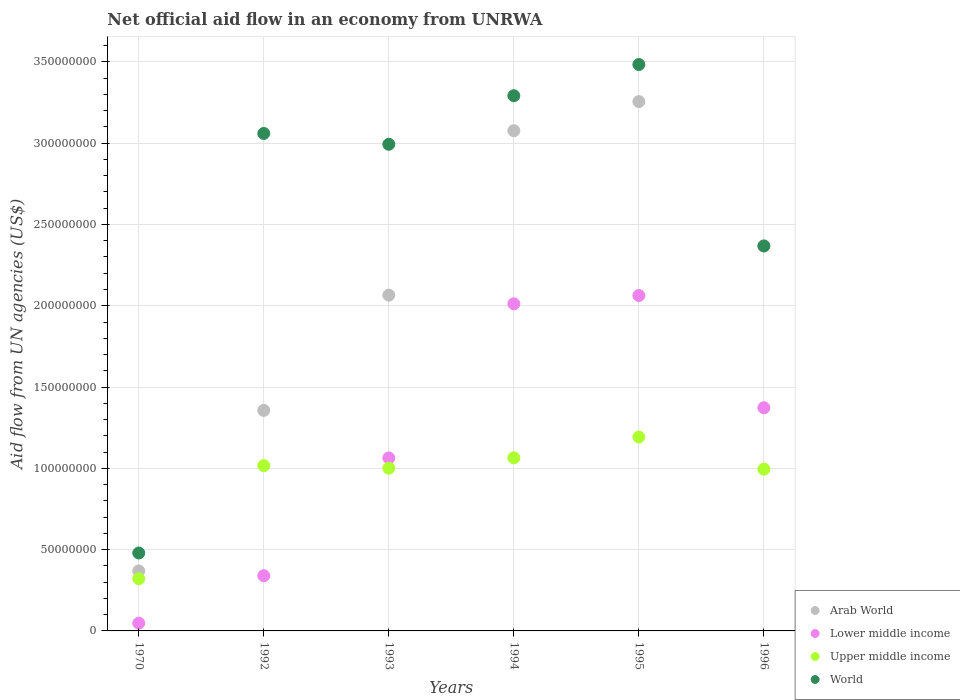How many different coloured dotlines are there?
Your answer should be compact. 4. What is the net official aid flow in Lower middle income in 1995?
Provide a short and direct response. 2.06e+08. Across all years, what is the maximum net official aid flow in Lower middle income?
Offer a terse response. 2.06e+08. Across all years, what is the minimum net official aid flow in Arab World?
Your answer should be very brief. 3.69e+07. In which year was the net official aid flow in Upper middle income maximum?
Ensure brevity in your answer.  1995. In which year was the net official aid flow in World minimum?
Provide a succinct answer. 1970. What is the total net official aid flow in World in the graph?
Your response must be concise. 1.57e+09. What is the difference between the net official aid flow in World in 1992 and that in 1994?
Keep it short and to the point. -2.32e+07. What is the difference between the net official aid flow in Lower middle income in 1993 and the net official aid flow in World in 1970?
Keep it short and to the point. 5.85e+07. What is the average net official aid flow in World per year?
Your answer should be compact. 2.61e+08. In the year 1970, what is the difference between the net official aid flow in Upper middle income and net official aid flow in Lower middle income?
Provide a short and direct response. 2.73e+07. In how many years, is the net official aid flow in World greater than 120000000 US$?
Your response must be concise. 5. What is the ratio of the net official aid flow in Upper middle income in 1970 to that in 1993?
Your response must be concise. 0.32. Is the net official aid flow in Lower middle income in 1992 less than that in 1993?
Ensure brevity in your answer.  Yes. Is the difference between the net official aid flow in Upper middle income in 1970 and 1994 greater than the difference between the net official aid flow in Lower middle income in 1970 and 1994?
Make the answer very short. Yes. What is the difference between the highest and the second highest net official aid flow in Arab World?
Your response must be concise. 1.79e+07. What is the difference between the highest and the lowest net official aid flow in World?
Your response must be concise. 3.00e+08. Is it the case that in every year, the sum of the net official aid flow in Lower middle income and net official aid flow in World  is greater than the sum of net official aid flow in Arab World and net official aid flow in Upper middle income?
Keep it short and to the point. No. Does the net official aid flow in Arab World monotonically increase over the years?
Offer a very short reply. No. Is the net official aid flow in World strictly less than the net official aid flow in Upper middle income over the years?
Provide a succinct answer. No. How many dotlines are there?
Your answer should be compact. 4. How many years are there in the graph?
Provide a succinct answer. 6. What is the difference between two consecutive major ticks on the Y-axis?
Ensure brevity in your answer.  5.00e+07. Does the graph contain grids?
Your response must be concise. Yes. Where does the legend appear in the graph?
Ensure brevity in your answer.  Bottom right. What is the title of the graph?
Give a very brief answer. Net official aid flow in an economy from UNRWA. What is the label or title of the Y-axis?
Your answer should be very brief. Aid flow from UN agencies (US$). What is the Aid flow from UN agencies (US$) of Arab World in 1970?
Ensure brevity in your answer.  3.69e+07. What is the Aid flow from UN agencies (US$) in Lower middle income in 1970?
Make the answer very short. 4.79e+06. What is the Aid flow from UN agencies (US$) of Upper middle income in 1970?
Offer a very short reply. 3.21e+07. What is the Aid flow from UN agencies (US$) of World in 1970?
Your answer should be compact. 4.79e+07. What is the Aid flow from UN agencies (US$) in Arab World in 1992?
Make the answer very short. 1.36e+08. What is the Aid flow from UN agencies (US$) of Lower middle income in 1992?
Your answer should be compact. 3.40e+07. What is the Aid flow from UN agencies (US$) in Upper middle income in 1992?
Offer a terse response. 1.02e+08. What is the Aid flow from UN agencies (US$) of World in 1992?
Your response must be concise. 3.06e+08. What is the Aid flow from UN agencies (US$) of Arab World in 1993?
Provide a succinct answer. 2.07e+08. What is the Aid flow from UN agencies (US$) of Lower middle income in 1993?
Offer a very short reply. 1.06e+08. What is the Aid flow from UN agencies (US$) in Upper middle income in 1993?
Your response must be concise. 1.00e+08. What is the Aid flow from UN agencies (US$) of World in 1993?
Keep it short and to the point. 2.99e+08. What is the Aid flow from UN agencies (US$) of Arab World in 1994?
Provide a succinct answer. 3.08e+08. What is the Aid flow from UN agencies (US$) of Lower middle income in 1994?
Provide a succinct answer. 2.01e+08. What is the Aid flow from UN agencies (US$) in Upper middle income in 1994?
Offer a very short reply. 1.06e+08. What is the Aid flow from UN agencies (US$) in World in 1994?
Offer a very short reply. 3.29e+08. What is the Aid flow from UN agencies (US$) in Arab World in 1995?
Ensure brevity in your answer.  3.26e+08. What is the Aid flow from UN agencies (US$) of Lower middle income in 1995?
Provide a succinct answer. 2.06e+08. What is the Aid flow from UN agencies (US$) in Upper middle income in 1995?
Provide a succinct answer. 1.19e+08. What is the Aid flow from UN agencies (US$) of World in 1995?
Your answer should be compact. 3.48e+08. What is the Aid flow from UN agencies (US$) of Arab World in 1996?
Ensure brevity in your answer.  2.37e+08. What is the Aid flow from UN agencies (US$) of Lower middle income in 1996?
Offer a terse response. 1.37e+08. What is the Aid flow from UN agencies (US$) in Upper middle income in 1996?
Offer a very short reply. 9.95e+07. What is the Aid flow from UN agencies (US$) in World in 1996?
Ensure brevity in your answer.  2.37e+08. Across all years, what is the maximum Aid flow from UN agencies (US$) in Arab World?
Offer a very short reply. 3.26e+08. Across all years, what is the maximum Aid flow from UN agencies (US$) of Lower middle income?
Offer a very short reply. 2.06e+08. Across all years, what is the maximum Aid flow from UN agencies (US$) of Upper middle income?
Your answer should be very brief. 1.19e+08. Across all years, what is the maximum Aid flow from UN agencies (US$) of World?
Offer a terse response. 3.48e+08. Across all years, what is the minimum Aid flow from UN agencies (US$) of Arab World?
Your response must be concise. 3.69e+07. Across all years, what is the minimum Aid flow from UN agencies (US$) in Lower middle income?
Provide a succinct answer. 4.79e+06. Across all years, what is the minimum Aid flow from UN agencies (US$) in Upper middle income?
Ensure brevity in your answer.  3.21e+07. Across all years, what is the minimum Aid flow from UN agencies (US$) of World?
Your response must be concise. 4.79e+07. What is the total Aid flow from UN agencies (US$) in Arab World in the graph?
Your response must be concise. 1.25e+09. What is the total Aid flow from UN agencies (US$) in Lower middle income in the graph?
Your response must be concise. 6.90e+08. What is the total Aid flow from UN agencies (US$) in Upper middle income in the graph?
Make the answer very short. 5.59e+08. What is the total Aid flow from UN agencies (US$) of World in the graph?
Keep it short and to the point. 1.57e+09. What is the difference between the Aid flow from UN agencies (US$) in Arab World in 1970 and that in 1992?
Provide a succinct answer. -9.87e+07. What is the difference between the Aid flow from UN agencies (US$) in Lower middle income in 1970 and that in 1992?
Provide a short and direct response. -2.92e+07. What is the difference between the Aid flow from UN agencies (US$) of Upper middle income in 1970 and that in 1992?
Your response must be concise. -6.96e+07. What is the difference between the Aid flow from UN agencies (US$) in World in 1970 and that in 1992?
Offer a terse response. -2.58e+08. What is the difference between the Aid flow from UN agencies (US$) in Arab World in 1970 and that in 1993?
Give a very brief answer. -1.70e+08. What is the difference between the Aid flow from UN agencies (US$) of Lower middle income in 1970 and that in 1993?
Provide a short and direct response. -1.02e+08. What is the difference between the Aid flow from UN agencies (US$) of Upper middle income in 1970 and that in 1993?
Your answer should be very brief. -6.80e+07. What is the difference between the Aid flow from UN agencies (US$) in World in 1970 and that in 1993?
Offer a terse response. -2.51e+08. What is the difference between the Aid flow from UN agencies (US$) of Arab World in 1970 and that in 1994?
Keep it short and to the point. -2.71e+08. What is the difference between the Aid flow from UN agencies (US$) of Lower middle income in 1970 and that in 1994?
Your answer should be compact. -1.96e+08. What is the difference between the Aid flow from UN agencies (US$) of Upper middle income in 1970 and that in 1994?
Your answer should be compact. -7.44e+07. What is the difference between the Aid flow from UN agencies (US$) of World in 1970 and that in 1994?
Offer a terse response. -2.81e+08. What is the difference between the Aid flow from UN agencies (US$) of Arab World in 1970 and that in 1995?
Provide a succinct answer. -2.89e+08. What is the difference between the Aid flow from UN agencies (US$) of Lower middle income in 1970 and that in 1995?
Offer a very short reply. -2.02e+08. What is the difference between the Aid flow from UN agencies (US$) in Upper middle income in 1970 and that in 1995?
Offer a very short reply. -8.72e+07. What is the difference between the Aid flow from UN agencies (US$) in World in 1970 and that in 1995?
Provide a short and direct response. -3.00e+08. What is the difference between the Aid flow from UN agencies (US$) of Arab World in 1970 and that in 1996?
Your answer should be compact. -2.00e+08. What is the difference between the Aid flow from UN agencies (US$) of Lower middle income in 1970 and that in 1996?
Your answer should be compact. -1.32e+08. What is the difference between the Aid flow from UN agencies (US$) of Upper middle income in 1970 and that in 1996?
Ensure brevity in your answer.  -6.74e+07. What is the difference between the Aid flow from UN agencies (US$) in World in 1970 and that in 1996?
Your answer should be very brief. -1.89e+08. What is the difference between the Aid flow from UN agencies (US$) in Arab World in 1992 and that in 1993?
Your response must be concise. -7.09e+07. What is the difference between the Aid flow from UN agencies (US$) of Lower middle income in 1992 and that in 1993?
Offer a very short reply. -7.24e+07. What is the difference between the Aid flow from UN agencies (US$) in Upper middle income in 1992 and that in 1993?
Your response must be concise. 1.57e+06. What is the difference between the Aid flow from UN agencies (US$) of World in 1992 and that in 1993?
Give a very brief answer. 6.65e+06. What is the difference between the Aid flow from UN agencies (US$) of Arab World in 1992 and that in 1994?
Your answer should be very brief. -1.72e+08. What is the difference between the Aid flow from UN agencies (US$) of Lower middle income in 1992 and that in 1994?
Offer a terse response. -1.67e+08. What is the difference between the Aid flow from UN agencies (US$) in Upper middle income in 1992 and that in 1994?
Offer a terse response. -4.80e+06. What is the difference between the Aid flow from UN agencies (US$) in World in 1992 and that in 1994?
Ensure brevity in your answer.  -2.32e+07. What is the difference between the Aid flow from UN agencies (US$) in Arab World in 1992 and that in 1995?
Ensure brevity in your answer.  -1.90e+08. What is the difference between the Aid flow from UN agencies (US$) of Lower middle income in 1992 and that in 1995?
Your answer should be very brief. -1.72e+08. What is the difference between the Aid flow from UN agencies (US$) of Upper middle income in 1992 and that in 1995?
Make the answer very short. -1.76e+07. What is the difference between the Aid flow from UN agencies (US$) in World in 1992 and that in 1995?
Your response must be concise. -4.24e+07. What is the difference between the Aid flow from UN agencies (US$) in Arab World in 1992 and that in 1996?
Provide a short and direct response. -1.01e+08. What is the difference between the Aid flow from UN agencies (US$) of Lower middle income in 1992 and that in 1996?
Make the answer very short. -1.03e+08. What is the difference between the Aid flow from UN agencies (US$) in Upper middle income in 1992 and that in 1996?
Keep it short and to the point. 2.18e+06. What is the difference between the Aid flow from UN agencies (US$) of World in 1992 and that in 1996?
Give a very brief answer. 6.92e+07. What is the difference between the Aid flow from UN agencies (US$) in Arab World in 1993 and that in 1994?
Offer a very short reply. -1.01e+08. What is the difference between the Aid flow from UN agencies (US$) in Lower middle income in 1993 and that in 1994?
Your answer should be compact. -9.48e+07. What is the difference between the Aid flow from UN agencies (US$) in Upper middle income in 1993 and that in 1994?
Ensure brevity in your answer.  -6.37e+06. What is the difference between the Aid flow from UN agencies (US$) in World in 1993 and that in 1994?
Give a very brief answer. -2.99e+07. What is the difference between the Aid flow from UN agencies (US$) of Arab World in 1993 and that in 1995?
Provide a succinct answer. -1.19e+08. What is the difference between the Aid flow from UN agencies (US$) in Lower middle income in 1993 and that in 1995?
Offer a terse response. -9.99e+07. What is the difference between the Aid flow from UN agencies (US$) of Upper middle income in 1993 and that in 1995?
Give a very brief answer. -1.92e+07. What is the difference between the Aid flow from UN agencies (US$) of World in 1993 and that in 1995?
Give a very brief answer. -4.91e+07. What is the difference between the Aid flow from UN agencies (US$) in Arab World in 1993 and that in 1996?
Your response must be concise. -3.03e+07. What is the difference between the Aid flow from UN agencies (US$) of Lower middle income in 1993 and that in 1996?
Give a very brief answer. -3.09e+07. What is the difference between the Aid flow from UN agencies (US$) in Upper middle income in 1993 and that in 1996?
Provide a succinct answer. 6.10e+05. What is the difference between the Aid flow from UN agencies (US$) of World in 1993 and that in 1996?
Your answer should be very brief. 6.26e+07. What is the difference between the Aid flow from UN agencies (US$) in Arab World in 1994 and that in 1995?
Give a very brief answer. -1.79e+07. What is the difference between the Aid flow from UN agencies (US$) in Lower middle income in 1994 and that in 1995?
Keep it short and to the point. -5.11e+06. What is the difference between the Aid flow from UN agencies (US$) in Upper middle income in 1994 and that in 1995?
Your answer should be very brief. -1.28e+07. What is the difference between the Aid flow from UN agencies (US$) in World in 1994 and that in 1995?
Make the answer very short. -1.92e+07. What is the difference between the Aid flow from UN agencies (US$) of Arab World in 1994 and that in 1996?
Your response must be concise. 7.09e+07. What is the difference between the Aid flow from UN agencies (US$) of Lower middle income in 1994 and that in 1996?
Make the answer very short. 6.39e+07. What is the difference between the Aid flow from UN agencies (US$) of Upper middle income in 1994 and that in 1996?
Provide a succinct answer. 6.98e+06. What is the difference between the Aid flow from UN agencies (US$) in World in 1994 and that in 1996?
Provide a succinct answer. 9.24e+07. What is the difference between the Aid flow from UN agencies (US$) of Arab World in 1995 and that in 1996?
Keep it short and to the point. 8.88e+07. What is the difference between the Aid flow from UN agencies (US$) of Lower middle income in 1995 and that in 1996?
Provide a short and direct response. 6.90e+07. What is the difference between the Aid flow from UN agencies (US$) of Upper middle income in 1995 and that in 1996?
Make the answer very short. 1.98e+07. What is the difference between the Aid flow from UN agencies (US$) in World in 1995 and that in 1996?
Provide a succinct answer. 1.12e+08. What is the difference between the Aid flow from UN agencies (US$) in Arab World in 1970 and the Aid flow from UN agencies (US$) in Lower middle income in 1992?
Make the answer very short. 2.95e+06. What is the difference between the Aid flow from UN agencies (US$) in Arab World in 1970 and the Aid flow from UN agencies (US$) in Upper middle income in 1992?
Make the answer very short. -6.48e+07. What is the difference between the Aid flow from UN agencies (US$) of Arab World in 1970 and the Aid flow from UN agencies (US$) of World in 1992?
Offer a terse response. -2.69e+08. What is the difference between the Aid flow from UN agencies (US$) in Lower middle income in 1970 and the Aid flow from UN agencies (US$) in Upper middle income in 1992?
Make the answer very short. -9.69e+07. What is the difference between the Aid flow from UN agencies (US$) of Lower middle income in 1970 and the Aid flow from UN agencies (US$) of World in 1992?
Keep it short and to the point. -3.01e+08. What is the difference between the Aid flow from UN agencies (US$) of Upper middle income in 1970 and the Aid flow from UN agencies (US$) of World in 1992?
Your answer should be very brief. -2.74e+08. What is the difference between the Aid flow from UN agencies (US$) in Arab World in 1970 and the Aid flow from UN agencies (US$) in Lower middle income in 1993?
Give a very brief answer. -6.95e+07. What is the difference between the Aid flow from UN agencies (US$) in Arab World in 1970 and the Aid flow from UN agencies (US$) in Upper middle income in 1993?
Your response must be concise. -6.32e+07. What is the difference between the Aid flow from UN agencies (US$) in Arab World in 1970 and the Aid flow from UN agencies (US$) in World in 1993?
Your answer should be compact. -2.62e+08. What is the difference between the Aid flow from UN agencies (US$) in Lower middle income in 1970 and the Aid flow from UN agencies (US$) in Upper middle income in 1993?
Make the answer very short. -9.53e+07. What is the difference between the Aid flow from UN agencies (US$) in Lower middle income in 1970 and the Aid flow from UN agencies (US$) in World in 1993?
Ensure brevity in your answer.  -2.95e+08. What is the difference between the Aid flow from UN agencies (US$) of Upper middle income in 1970 and the Aid flow from UN agencies (US$) of World in 1993?
Make the answer very short. -2.67e+08. What is the difference between the Aid flow from UN agencies (US$) of Arab World in 1970 and the Aid flow from UN agencies (US$) of Lower middle income in 1994?
Provide a succinct answer. -1.64e+08. What is the difference between the Aid flow from UN agencies (US$) of Arab World in 1970 and the Aid flow from UN agencies (US$) of Upper middle income in 1994?
Your answer should be very brief. -6.96e+07. What is the difference between the Aid flow from UN agencies (US$) in Arab World in 1970 and the Aid flow from UN agencies (US$) in World in 1994?
Your answer should be compact. -2.92e+08. What is the difference between the Aid flow from UN agencies (US$) of Lower middle income in 1970 and the Aid flow from UN agencies (US$) of Upper middle income in 1994?
Provide a short and direct response. -1.02e+08. What is the difference between the Aid flow from UN agencies (US$) of Lower middle income in 1970 and the Aid flow from UN agencies (US$) of World in 1994?
Make the answer very short. -3.24e+08. What is the difference between the Aid flow from UN agencies (US$) of Upper middle income in 1970 and the Aid flow from UN agencies (US$) of World in 1994?
Offer a very short reply. -2.97e+08. What is the difference between the Aid flow from UN agencies (US$) in Arab World in 1970 and the Aid flow from UN agencies (US$) in Lower middle income in 1995?
Offer a very short reply. -1.69e+08. What is the difference between the Aid flow from UN agencies (US$) of Arab World in 1970 and the Aid flow from UN agencies (US$) of Upper middle income in 1995?
Offer a very short reply. -8.24e+07. What is the difference between the Aid flow from UN agencies (US$) of Arab World in 1970 and the Aid flow from UN agencies (US$) of World in 1995?
Give a very brief answer. -3.11e+08. What is the difference between the Aid flow from UN agencies (US$) in Lower middle income in 1970 and the Aid flow from UN agencies (US$) in Upper middle income in 1995?
Keep it short and to the point. -1.14e+08. What is the difference between the Aid flow from UN agencies (US$) of Lower middle income in 1970 and the Aid flow from UN agencies (US$) of World in 1995?
Your response must be concise. -3.44e+08. What is the difference between the Aid flow from UN agencies (US$) in Upper middle income in 1970 and the Aid flow from UN agencies (US$) in World in 1995?
Your answer should be very brief. -3.16e+08. What is the difference between the Aid flow from UN agencies (US$) in Arab World in 1970 and the Aid flow from UN agencies (US$) in Lower middle income in 1996?
Offer a terse response. -1.00e+08. What is the difference between the Aid flow from UN agencies (US$) in Arab World in 1970 and the Aid flow from UN agencies (US$) in Upper middle income in 1996?
Your answer should be very brief. -6.26e+07. What is the difference between the Aid flow from UN agencies (US$) in Arab World in 1970 and the Aid flow from UN agencies (US$) in World in 1996?
Your answer should be very brief. -2.00e+08. What is the difference between the Aid flow from UN agencies (US$) of Lower middle income in 1970 and the Aid flow from UN agencies (US$) of Upper middle income in 1996?
Provide a short and direct response. -9.47e+07. What is the difference between the Aid flow from UN agencies (US$) of Lower middle income in 1970 and the Aid flow from UN agencies (US$) of World in 1996?
Offer a very short reply. -2.32e+08. What is the difference between the Aid flow from UN agencies (US$) in Upper middle income in 1970 and the Aid flow from UN agencies (US$) in World in 1996?
Ensure brevity in your answer.  -2.05e+08. What is the difference between the Aid flow from UN agencies (US$) in Arab World in 1992 and the Aid flow from UN agencies (US$) in Lower middle income in 1993?
Provide a short and direct response. 2.92e+07. What is the difference between the Aid flow from UN agencies (US$) of Arab World in 1992 and the Aid flow from UN agencies (US$) of Upper middle income in 1993?
Provide a short and direct response. 3.55e+07. What is the difference between the Aid flow from UN agencies (US$) of Arab World in 1992 and the Aid flow from UN agencies (US$) of World in 1993?
Make the answer very short. -1.64e+08. What is the difference between the Aid flow from UN agencies (US$) in Lower middle income in 1992 and the Aid flow from UN agencies (US$) in Upper middle income in 1993?
Make the answer very short. -6.62e+07. What is the difference between the Aid flow from UN agencies (US$) in Lower middle income in 1992 and the Aid flow from UN agencies (US$) in World in 1993?
Offer a terse response. -2.65e+08. What is the difference between the Aid flow from UN agencies (US$) of Upper middle income in 1992 and the Aid flow from UN agencies (US$) of World in 1993?
Make the answer very short. -1.98e+08. What is the difference between the Aid flow from UN agencies (US$) of Arab World in 1992 and the Aid flow from UN agencies (US$) of Lower middle income in 1994?
Keep it short and to the point. -6.56e+07. What is the difference between the Aid flow from UN agencies (US$) of Arab World in 1992 and the Aid flow from UN agencies (US$) of Upper middle income in 1994?
Offer a very short reply. 2.92e+07. What is the difference between the Aid flow from UN agencies (US$) in Arab World in 1992 and the Aid flow from UN agencies (US$) in World in 1994?
Give a very brief answer. -1.94e+08. What is the difference between the Aid flow from UN agencies (US$) of Lower middle income in 1992 and the Aid flow from UN agencies (US$) of Upper middle income in 1994?
Provide a short and direct response. -7.25e+07. What is the difference between the Aid flow from UN agencies (US$) in Lower middle income in 1992 and the Aid flow from UN agencies (US$) in World in 1994?
Offer a terse response. -2.95e+08. What is the difference between the Aid flow from UN agencies (US$) in Upper middle income in 1992 and the Aid flow from UN agencies (US$) in World in 1994?
Offer a terse response. -2.28e+08. What is the difference between the Aid flow from UN agencies (US$) of Arab World in 1992 and the Aid flow from UN agencies (US$) of Lower middle income in 1995?
Ensure brevity in your answer.  -7.07e+07. What is the difference between the Aid flow from UN agencies (US$) of Arab World in 1992 and the Aid flow from UN agencies (US$) of Upper middle income in 1995?
Your answer should be compact. 1.64e+07. What is the difference between the Aid flow from UN agencies (US$) of Arab World in 1992 and the Aid flow from UN agencies (US$) of World in 1995?
Make the answer very short. -2.13e+08. What is the difference between the Aid flow from UN agencies (US$) of Lower middle income in 1992 and the Aid flow from UN agencies (US$) of Upper middle income in 1995?
Offer a very short reply. -8.53e+07. What is the difference between the Aid flow from UN agencies (US$) of Lower middle income in 1992 and the Aid flow from UN agencies (US$) of World in 1995?
Give a very brief answer. -3.14e+08. What is the difference between the Aid flow from UN agencies (US$) in Upper middle income in 1992 and the Aid flow from UN agencies (US$) in World in 1995?
Your answer should be very brief. -2.47e+08. What is the difference between the Aid flow from UN agencies (US$) of Arab World in 1992 and the Aid flow from UN agencies (US$) of Lower middle income in 1996?
Keep it short and to the point. -1.65e+06. What is the difference between the Aid flow from UN agencies (US$) in Arab World in 1992 and the Aid flow from UN agencies (US$) in Upper middle income in 1996?
Provide a short and direct response. 3.61e+07. What is the difference between the Aid flow from UN agencies (US$) of Arab World in 1992 and the Aid flow from UN agencies (US$) of World in 1996?
Offer a very short reply. -1.01e+08. What is the difference between the Aid flow from UN agencies (US$) in Lower middle income in 1992 and the Aid flow from UN agencies (US$) in Upper middle income in 1996?
Make the answer very short. -6.56e+07. What is the difference between the Aid flow from UN agencies (US$) of Lower middle income in 1992 and the Aid flow from UN agencies (US$) of World in 1996?
Offer a very short reply. -2.03e+08. What is the difference between the Aid flow from UN agencies (US$) in Upper middle income in 1992 and the Aid flow from UN agencies (US$) in World in 1996?
Ensure brevity in your answer.  -1.35e+08. What is the difference between the Aid flow from UN agencies (US$) of Arab World in 1993 and the Aid flow from UN agencies (US$) of Lower middle income in 1994?
Ensure brevity in your answer.  5.31e+06. What is the difference between the Aid flow from UN agencies (US$) of Arab World in 1993 and the Aid flow from UN agencies (US$) of Upper middle income in 1994?
Your answer should be very brief. 1.00e+08. What is the difference between the Aid flow from UN agencies (US$) in Arab World in 1993 and the Aid flow from UN agencies (US$) in World in 1994?
Give a very brief answer. -1.23e+08. What is the difference between the Aid flow from UN agencies (US$) of Lower middle income in 1993 and the Aid flow from UN agencies (US$) of Upper middle income in 1994?
Give a very brief answer. -8.00e+04. What is the difference between the Aid flow from UN agencies (US$) in Lower middle income in 1993 and the Aid flow from UN agencies (US$) in World in 1994?
Provide a short and direct response. -2.23e+08. What is the difference between the Aid flow from UN agencies (US$) of Upper middle income in 1993 and the Aid flow from UN agencies (US$) of World in 1994?
Your response must be concise. -2.29e+08. What is the difference between the Aid flow from UN agencies (US$) in Arab World in 1993 and the Aid flow from UN agencies (US$) in Upper middle income in 1995?
Keep it short and to the point. 8.72e+07. What is the difference between the Aid flow from UN agencies (US$) of Arab World in 1993 and the Aid flow from UN agencies (US$) of World in 1995?
Your response must be concise. -1.42e+08. What is the difference between the Aid flow from UN agencies (US$) of Lower middle income in 1993 and the Aid flow from UN agencies (US$) of Upper middle income in 1995?
Provide a succinct answer. -1.29e+07. What is the difference between the Aid flow from UN agencies (US$) in Lower middle income in 1993 and the Aid flow from UN agencies (US$) in World in 1995?
Offer a very short reply. -2.42e+08. What is the difference between the Aid flow from UN agencies (US$) in Upper middle income in 1993 and the Aid flow from UN agencies (US$) in World in 1995?
Offer a very short reply. -2.48e+08. What is the difference between the Aid flow from UN agencies (US$) in Arab World in 1993 and the Aid flow from UN agencies (US$) in Lower middle income in 1996?
Keep it short and to the point. 6.92e+07. What is the difference between the Aid flow from UN agencies (US$) in Arab World in 1993 and the Aid flow from UN agencies (US$) in Upper middle income in 1996?
Provide a short and direct response. 1.07e+08. What is the difference between the Aid flow from UN agencies (US$) of Arab World in 1993 and the Aid flow from UN agencies (US$) of World in 1996?
Provide a short and direct response. -3.03e+07. What is the difference between the Aid flow from UN agencies (US$) of Lower middle income in 1993 and the Aid flow from UN agencies (US$) of Upper middle income in 1996?
Provide a succinct answer. 6.90e+06. What is the difference between the Aid flow from UN agencies (US$) of Lower middle income in 1993 and the Aid flow from UN agencies (US$) of World in 1996?
Ensure brevity in your answer.  -1.30e+08. What is the difference between the Aid flow from UN agencies (US$) in Upper middle income in 1993 and the Aid flow from UN agencies (US$) in World in 1996?
Your answer should be compact. -1.37e+08. What is the difference between the Aid flow from UN agencies (US$) of Arab World in 1994 and the Aid flow from UN agencies (US$) of Lower middle income in 1995?
Provide a short and direct response. 1.01e+08. What is the difference between the Aid flow from UN agencies (US$) of Arab World in 1994 and the Aid flow from UN agencies (US$) of Upper middle income in 1995?
Provide a short and direct response. 1.88e+08. What is the difference between the Aid flow from UN agencies (US$) in Arab World in 1994 and the Aid flow from UN agencies (US$) in World in 1995?
Offer a terse response. -4.07e+07. What is the difference between the Aid flow from UN agencies (US$) of Lower middle income in 1994 and the Aid flow from UN agencies (US$) of Upper middle income in 1995?
Offer a very short reply. 8.19e+07. What is the difference between the Aid flow from UN agencies (US$) in Lower middle income in 1994 and the Aid flow from UN agencies (US$) in World in 1995?
Your response must be concise. -1.47e+08. What is the difference between the Aid flow from UN agencies (US$) in Upper middle income in 1994 and the Aid flow from UN agencies (US$) in World in 1995?
Provide a short and direct response. -2.42e+08. What is the difference between the Aid flow from UN agencies (US$) of Arab World in 1994 and the Aid flow from UN agencies (US$) of Lower middle income in 1996?
Give a very brief answer. 1.70e+08. What is the difference between the Aid flow from UN agencies (US$) in Arab World in 1994 and the Aid flow from UN agencies (US$) in Upper middle income in 1996?
Offer a terse response. 2.08e+08. What is the difference between the Aid flow from UN agencies (US$) of Arab World in 1994 and the Aid flow from UN agencies (US$) of World in 1996?
Offer a very short reply. 7.09e+07. What is the difference between the Aid flow from UN agencies (US$) in Lower middle income in 1994 and the Aid flow from UN agencies (US$) in Upper middle income in 1996?
Give a very brief answer. 1.02e+08. What is the difference between the Aid flow from UN agencies (US$) of Lower middle income in 1994 and the Aid flow from UN agencies (US$) of World in 1996?
Your response must be concise. -3.56e+07. What is the difference between the Aid flow from UN agencies (US$) in Upper middle income in 1994 and the Aid flow from UN agencies (US$) in World in 1996?
Give a very brief answer. -1.30e+08. What is the difference between the Aid flow from UN agencies (US$) in Arab World in 1995 and the Aid flow from UN agencies (US$) in Lower middle income in 1996?
Ensure brevity in your answer.  1.88e+08. What is the difference between the Aid flow from UN agencies (US$) in Arab World in 1995 and the Aid flow from UN agencies (US$) in Upper middle income in 1996?
Give a very brief answer. 2.26e+08. What is the difference between the Aid flow from UN agencies (US$) of Arab World in 1995 and the Aid flow from UN agencies (US$) of World in 1996?
Ensure brevity in your answer.  8.88e+07. What is the difference between the Aid flow from UN agencies (US$) in Lower middle income in 1995 and the Aid flow from UN agencies (US$) in Upper middle income in 1996?
Your response must be concise. 1.07e+08. What is the difference between the Aid flow from UN agencies (US$) of Lower middle income in 1995 and the Aid flow from UN agencies (US$) of World in 1996?
Provide a short and direct response. -3.05e+07. What is the difference between the Aid flow from UN agencies (US$) of Upper middle income in 1995 and the Aid flow from UN agencies (US$) of World in 1996?
Offer a very short reply. -1.18e+08. What is the average Aid flow from UN agencies (US$) of Arab World per year?
Ensure brevity in your answer.  2.08e+08. What is the average Aid flow from UN agencies (US$) of Lower middle income per year?
Provide a succinct answer. 1.15e+08. What is the average Aid flow from UN agencies (US$) of Upper middle income per year?
Offer a terse response. 9.32e+07. What is the average Aid flow from UN agencies (US$) of World per year?
Offer a very short reply. 2.61e+08. In the year 1970, what is the difference between the Aid flow from UN agencies (US$) in Arab World and Aid flow from UN agencies (US$) in Lower middle income?
Provide a succinct answer. 3.21e+07. In the year 1970, what is the difference between the Aid flow from UN agencies (US$) of Arab World and Aid flow from UN agencies (US$) of Upper middle income?
Your answer should be very brief. 4.79e+06. In the year 1970, what is the difference between the Aid flow from UN agencies (US$) in Arab World and Aid flow from UN agencies (US$) in World?
Offer a terse response. -1.10e+07. In the year 1970, what is the difference between the Aid flow from UN agencies (US$) in Lower middle income and Aid flow from UN agencies (US$) in Upper middle income?
Provide a short and direct response. -2.73e+07. In the year 1970, what is the difference between the Aid flow from UN agencies (US$) in Lower middle income and Aid flow from UN agencies (US$) in World?
Your answer should be very brief. -4.31e+07. In the year 1970, what is the difference between the Aid flow from UN agencies (US$) of Upper middle income and Aid flow from UN agencies (US$) of World?
Offer a terse response. -1.58e+07. In the year 1992, what is the difference between the Aid flow from UN agencies (US$) in Arab World and Aid flow from UN agencies (US$) in Lower middle income?
Your answer should be very brief. 1.02e+08. In the year 1992, what is the difference between the Aid flow from UN agencies (US$) of Arab World and Aid flow from UN agencies (US$) of Upper middle income?
Offer a very short reply. 3.40e+07. In the year 1992, what is the difference between the Aid flow from UN agencies (US$) in Arab World and Aid flow from UN agencies (US$) in World?
Ensure brevity in your answer.  -1.70e+08. In the year 1992, what is the difference between the Aid flow from UN agencies (US$) of Lower middle income and Aid flow from UN agencies (US$) of Upper middle income?
Provide a short and direct response. -6.77e+07. In the year 1992, what is the difference between the Aid flow from UN agencies (US$) in Lower middle income and Aid flow from UN agencies (US$) in World?
Ensure brevity in your answer.  -2.72e+08. In the year 1992, what is the difference between the Aid flow from UN agencies (US$) in Upper middle income and Aid flow from UN agencies (US$) in World?
Provide a succinct answer. -2.04e+08. In the year 1993, what is the difference between the Aid flow from UN agencies (US$) of Arab World and Aid flow from UN agencies (US$) of Lower middle income?
Provide a succinct answer. 1.00e+08. In the year 1993, what is the difference between the Aid flow from UN agencies (US$) of Arab World and Aid flow from UN agencies (US$) of Upper middle income?
Offer a very short reply. 1.06e+08. In the year 1993, what is the difference between the Aid flow from UN agencies (US$) in Arab World and Aid flow from UN agencies (US$) in World?
Your answer should be very brief. -9.28e+07. In the year 1993, what is the difference between the Aid flow from UN agencies (US$) of Lower middle income and Aid flow from UN agencies (US$) of Upper middle income?
Offer a terse response. 6.29e+06. In the year 1993, what is the difference between the Aid flow from UN agencies (US$) of Lower middle income and Aid flow from UN agencies (US$) of World?
Your response must be concise. -1.93e+08. In the year 1993, what is the difference between the Aid flow from UN agencies (US$) in Upper middle income and Aid flow from UN agencies (US$) in World?
Your answer should be compact. -1.99e+08. In the year 1994, what is the difference between the Aid flow from UN agencies (US$) in Arab World and Aid flow from UN agencies (US$) in Lower middle income?
Your answer should be very brief. 1.06e+08. In the year 1994, what is the difference between the Aid flow from UN agencies (US$) of Arab World and Aid flow from UN agencies (US$) of Upper middle income?
Your answer should be compact. 2.01e+08. In the year 1994, what is the difference between the Aid flow from UN agencies (US$) in Arab World and Aid flow from UN agencies (US$) in World?
Ensure brevity in your answer.  -2.15e+07. In the year 1994, what is the difference between the Aid flow from UN agencies (US$) of Lower middle income and Aid flow from UN agencies (US$) of Upper middle income?
Your answer should be very brief. 9.47e+07. In the year 1994, what is the difference between the Aid flow from UN agencies (US$) of Lower middle income and Aid flow from UN agencies (US$) of World?
Your answer should be very brief. -1.28e+08. In the year 1994, what is the difference between the Aid flow from UN agencies (US$) of Upper middle income and Aid flow from UN agencies (US$) of World?
Your answer should be very brief. -2.23e+08. In the year 1995, what is the difference between the Aid flow from UN agencies (US$) in Arab World and Aid flow from UN agencies (US$) in Lower middle income?
Offer a terse response. 1.19e+08. In the year 1995, what is the difference between the Aid flow from UN agencies (US$) in Arab World and Aid flow from UN agencies (US$) in Upper middle income?
Keep it short and to the point. 2.06e+08. In the year 1995, what is the difference between the Aid flow from UN agencies (US$) in Arab World and Aid flow from UN agencies (US$) in World?
Your answer should be compact. -2.28e+07. In the year 1995, what is the difference between the Aid flow from UN agencies (US$) of Lower middle income and Aid flow from UN agencies (US$) of Upper middle income?
Your response must be concise. 8.70e+07. In the year 1995, what is the difference between the Aid flow from UN agencies (US$) of Lower middle income and Aid flow from UN agencies (US$) of World?
Provide a succinct answer. -1.42e+08. In the year 1995, what is the difference between the Aid flow from UN agencies (US$) of Upper middle income and Aid flow from UN agencies (US$) of World?
Offer a very short reply. -2.29e+08. In the year 1996, what is the difference between the Aid flow from UN agencies (US$) of Arab World and Aid flow from UN agencies (US$) of Lower middle income?
Your answer should be very brief. 9.95e+07. In the year 1996, what is the difference between the Aid flow from UN agencies (US$) in Arab World and Aid flow from UN agencies (US$) in Upper middle income?
Offer a very short reply. 1.37e+08. In the year 1996, what is the difference between the Aid flow from UN agencies (US$) in Arab World and Aid flow from UN agencies (US$) in World?
Give a very brief answer. 0. In the year 1996, what is the difference between the Aid flow from UN agencies (US$) of Lower middle income and Aid flow from UN agencies (US$) of Upper middle income?
Provide a short and direct response. 3.78e+07. In the year 1996, what is the difference between the Aid flow from UN agencies (US$) of Lower middle income and Aid flow from UN agencies (US$) of World?
Ensure brevity in your answer.  -9.95e+07. In the year 1996, what is the difference between the Aid flow from UN agencies (US$) in Upper middle income and Aid flow from UN agencies (US$) in World?
Give a very brief answer. -1.37e+08. What is the ratio of the Aid flow from UN agencies (US$) in Arab World in 1970 to that in 1992?
Offer a terse response. 0.27. What is the ratio of the Aid flow from UN agencies (US$) in Lower middle income in 1970 to that in 1992?
Offer a terse response. 0.14. What is the ratio of the Aid flow from UN agencies (US$) in Upper middle income in 1970 to that in 1992?
Make the answer very short. 0.32. What is the ratio of the Aid flow from UN agencies (US$) of World in 1970 to that in 1992?
Offer a terse response. 0.16. What is the ratio of the Aid flow from UN agencies (US$) of Arab World in 1970 to that in 1993?
Provide a succinct answer. 0.18. What is the ratio of the Aid flow from UN agencies (US$) in Lower middle income in 1970 to that in 1993?
Your answer should be compact. 0.04. What is the ratio of the Aid flow from UN agencies (US$) of Upper middle income in 1970 to that in 1993?
Give a very brief answer. 0.32. What is the ratio of the Aid flow from UN agencies (US$) in World in 1970 to that in 1993?
Your answer should be compact. 0.16. What is the ratio of the Aid flow from UN agencies (US$) in Arab World in 1970 to that in 1994?
Offer a terse response. 0.12. What is the ratio of the Aid flow from UN agencies (US$) in Lower middle income in 1970 to that in 1994?
Make the answer very short. 0.02. What is the ratio of the Aid flow from UN agencies (US$) in Upper middle income in 1970 to that in 1994?
Offer a terse response. 0.3. What is the ratio of the Aid flow from UN agencies (US$) of World in 1970 to that in 1994?
Provide a short and direct response. 0.15. What is the ratio of the Aid flow from UN agencies (US$) of Arab World in 1970 to that in 1995?
Keep it short and to the point. 0.11. What is the ratio of the Aid flow from UN agencies (US$) in Lower middle income in 1970 to that in 1995?
Ensure brevity in your answer.  0.02. What is the ratio of the Aid flow from UN agencies (US$) of Upper middle income in 1970 to that in 1995?
Make the answer very short. 0.27. What is the ratio of the Aid flow from UN agencies (US$) of World in 1970 to that in 1995?
Offer a terse response. 0.14. What is the ratio of the Aid flow from UN agencies (US$) of Arab World in 1970 to that in 1996?
Make the answer very short. 0.16. What is the ratio of the Aid flow from UN agencies (US$) in Lower middle income in 1970 to that in 1996?
Provide a succinct answer. 0.03. What is the ratio of the Aid flow from UN agencies (US$) of Upper middle income in 1970 to that in 1996?
Provide a succinct answer. 0.32. What is the ratio of the Aid flow from UN agencies (US$) in World in 1970 to that in 1996?
Your answer should be compact. 0.2. What is the ratio of the Aid flow from UN agencies (US$) in Arab World in 1992 to that in 1993?
Ensure brevity in your answer.  0.66. What is the ratio of the Aid flow from UN agencies (US$) in Lower middle income in 1992 to that in 1993?
Provide a succinct answer. 0.32. What is the ratio of the Aid flow from UN agencies (US$) in Upper middle income in 1992 to that in 1993?
Offer a very short reply. 1.02. What is the ratio of the Aid flow from UN agencies (US$) of World in 1992 to that in 1993?
Keep it short and to the point. 1.02. What is the ratio of the Aid flow from UN agencies (US$) in Arab World in 1992 to that in 1994?
Offer a terse response. 0.44. What is the ratio of the Aid flow from UN agencies (US$) in Lower middle income in 1992 to that in 1994?
Your response must be concise. 0.17. What is the ratio of the Aid flow from UN agencies (US$) of Upper middle income in 1992 to that in 1994?
Your response must be concise. 0.95. What is the ratio of the Aid flow from UN agencies (US$) in World in 1992 to that in 1994?
Your answer should be compact. 0.93. What is the ratio of the Aid flow from UN agencies (US$) in Arab World in 1992 to that in 1995?
Offer a very short reply. 0.42. What is the ratio of the Aid flow from UN agencies (US$) in Lower middle income in 1992 to that in 1995?
Provide a short and direct response. 0.16. What is the ratio of the Aid flow from UN agencies (US$) of Upper middle income in 1992 to that in 1995?
Your answer should be compact. 0.85. What is the ratio of the Aid flow from UN agencies (US$) of World in 1992 to that in 1995?
Give a very brief answer. 0.88. What is the ratio of the Aid flow from UN agencies (US$) in Arab World in 1992 to that in 1996?
Ensure brevity in your answer.  0.57. What is the ratio of the Aid flow from UN agencies (US$) in Lower middle income in 1992 to that in 1996?
Your answer should be very brief. 0.25. What is the ratio of the Aid flow from UN agencies (US$) of Upper middle income in 1992 to that in 1996?
Keep it short and to the point. 1.02. What is the ratio of the Aid flow from UN agencies (US$) of World in 1992 to that in 1996?
Offer a terse response. 1.29. What is the ratio of the Aid flow from UN agencies (US$) of Arab World in 1993 to that in 1994?
Give a very brief answer. 0.67. What is the ratio of the Aid flow from UN agencies (US$) of Lower middle income in 1993 to that in 1994?
Ensure brevity in your answer.  0.53. What is the ratio of the Aid flow from UN agencies (US$) in Upper middle income in 1993 to that in 1994?
Ensure brevity in your answer.  0.94. What is the ratio of the Aid flow from UN agencies (US$) in World in 1993 to that in 1994?
Provide a short and direct response. 0.91. What is the ratio of the Aid flow from UN agencies (US$) of Arab World in 1993 to that in 1995?
Offer a terse response. 0.63. What is the ratio of the Aid flow from UN agencies (US$) in Lower middle income in 1993 to that in 1995?
Provide a succinct answer. 0.52. What is the ratio of the Aid flow from UN agencies (US$) of Upper middle income in 1993 to that in 1995?
Your answer should be compact. 0.84. What is the ratio of the Aid flow from UN agencies (US$) of World in 1993 to that in 1995?
Make the answer very short. 0.86. What is the ratio of the Aid flow from UN agencies (US$) in Arab World in 1993 to that in 1996?
Provide a succinct answer. 0.87. What is the ratio of the Aid flow from UN agencies (US$) of Lower middle income in 1993 to that in 1996?
Ensure brevity in your answer.  0.78. What is the ratio of the Aid flow from UN agencies (US$) in Upper middle income in 1993 to that in 1996?
Your answer should be very brief. 1.01. What is the ratio of the Aid flow from UN agencies (US$) in World in 1993 to that in 1996?
Keep it short and to the point. 1.26. What is the ratio of the Aid flow from UN agencies (US$) in Arab World in 1994 to that in 1995?
Make the answer very short. 0.95. What is the ratio of the Aid flow from UN agencies (US$) of Lower middle income in 1994 to that in 1995?
Provide a short and direct response. 0.98. What is the ratio of the Aid flow from UN agencies (US$) in Upper middle income in 1994 to that in 1995?
Ensure brevity in your answer.  0.89. What is the ratio of the Aid flow from UN agencies (US$) of World in 1994 to that in 1995?
Offer a very short reply. 0.94. What is the ratio of the Aid flow from UN agencies (US$) of Arab World in 1994 to that in 1996?
Offer a very short reply. 1.3. What is the ratio of the Aid flow from UN agencies (US$) of Lower middle income in 1994 to that in 1996?
Offer a very short reply. 1.47. What is the ratio of the Aid flow from UN agencies (US$) in Upper middle income in 1994 to that in 1996?
Your answer should be compact. 1.07. What is the ratio of the Aid flow from UN agencies (US$) of World in 1994 to that in 1996?
Provide a succinct answer. 1.39. What is the ratio of the Aid flow from UN agencies (US$) in Arab World in 1995 to that in 1996?
Offer a very short reply. 1.38. What is the ratio of the Aid flow from UN agencies (US$) of Lower middle income in 1995 to that in 1996?
Your response must be concise. 1.5. What is the ratio of the Aid flow from UN agencies (US$) of Upper middle income in 1995 to that in 1996?
Provide a succinct answer. 1.2. What is the ratio of the Aid flow from UN agencies (US$) in World in 1995 to that in 1996?
Ensure brevity in your answer.  1.47. What is the difference between the highest and the second highest Aid flow from UN agencies (US$) in Arab World?
Your answer should be very brief. 1.79e+07. What is the difference between the highest and the second highest Aid flow from UN agencies (US$) of Lower middle income?
Provide a short and direct response. 5.11e+06. What is the difference between the highest and the second highest Aid flow from UN agencies (US$) in Upper middle income?
Give a very brief answer. 1.28e+07. What is the difference between the highest and the second highest Aid flow from UN agencies (US$) in World?
Provide a succinct answer. 1.92e+07. What is the difference between the highest and the lowest Aid flow from UN agencies (US$) in Arab World?
Provide a succinct answer. 2.89e+08. What is the difference between the highest and the lowest Aid flow from UN agencies (US$) in Lower middle income?
Make the answer very short. 2.02e+08. What is the difference between the highest and the lowest Aid flow from UN agencies (US$) in Upper middle income?
Your response must be concise. 8.72e+07. What is the difference between the highest and the lowest Aid flow from UN agencies (US$) in World?
Ensure brevity in your answer.  3.00e+08. 